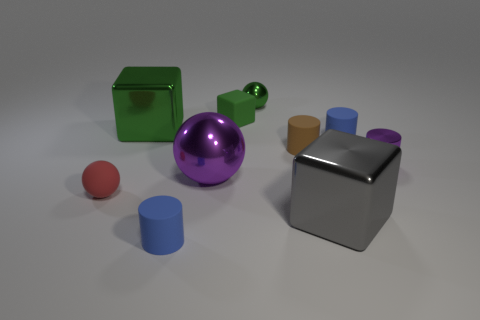Is the color of the tiny metallic object that is in front of the small brown cylinder the same as the metal ball in front of the large green thing? Yes, the color of the tiny metallic object in front of the small brown cylinder and the larger metal ball in front of the green cube are both reflective silver, indicating that the objects likely share a similar material composition. 